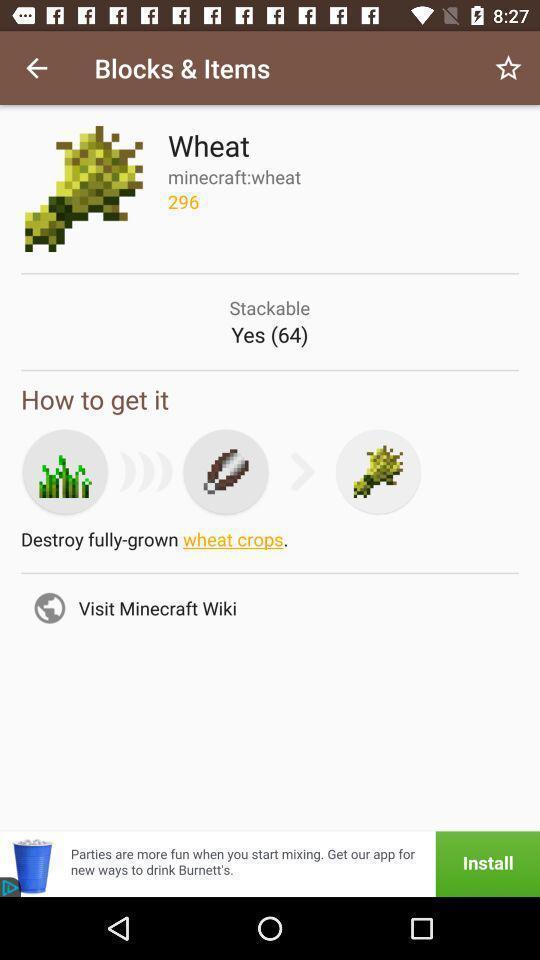What can you discern from this picture? Screen showing how to get wheat. 